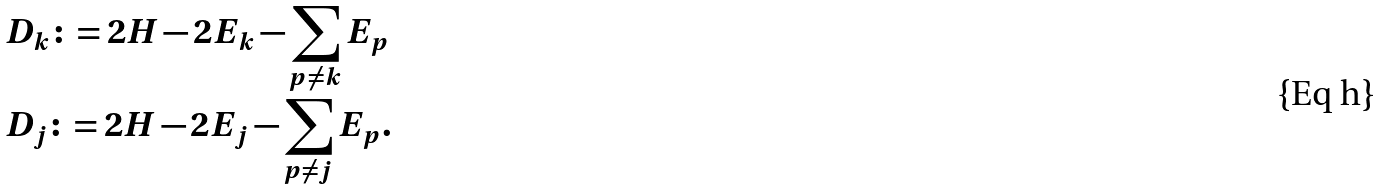Convert formula to latex. <formula><loc_0><loc_0><loc_500><loc_500>& D _ { k } \colon = 2 H - 2 E _ { k } - \sum _ { p \neq k } E _ { p } \\ & D _ { j } \colon = 2 H - 2 E _ { j } - \sum _ { p \neq j } E _ { p } .</formula> 